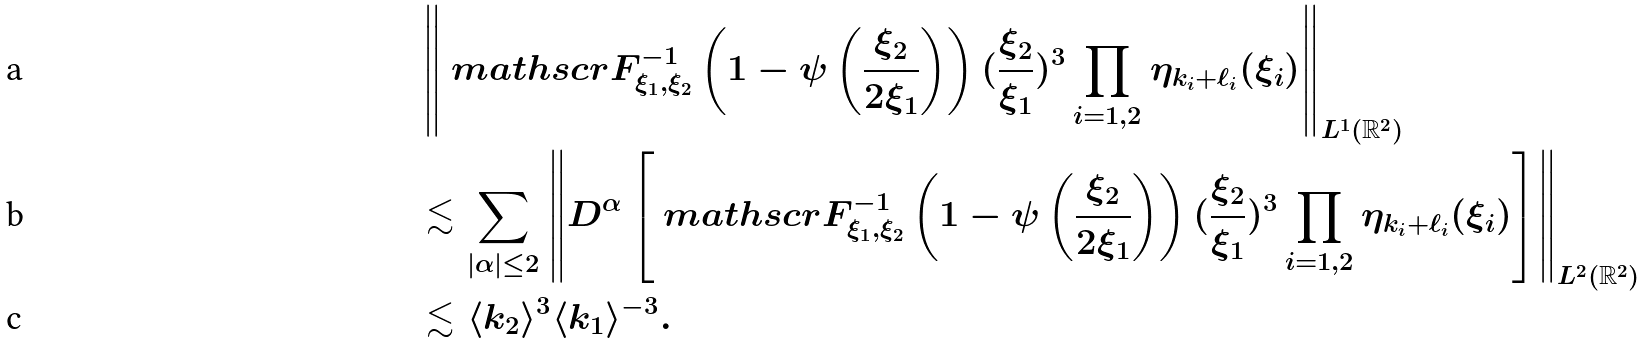Convert formula to latex. <formula><loc_0><loc_0><loc_500><loc_500>& \left \| \ m a t h s c r { F } ^ { - 1 } _ { \xi _ { 1 } , \xi _ { 2 } } \left ( 1 - \psi \left ( \frac { \xi _ { 2 } } { 2 \xi _ { 1 } } \right ) \right ) ( \frac { \xi _ { 2 } } { \xi _ { 1 } } ) ^ { 3 } \prod _ { i = 1 , 2 } \eta _ { k _ { i } + \ell _ { i } } ( \xi _ { i } ) \right \| _ { L ^ { 1 } ( \mathbb { R } ^ { 2 } ) } \\ & \lesssim \sum _ { | \alpha | \leq 2 } \left \| D ^ { \alpha } \left [ \ m a t h s c r { F } ^ { - 1 } _ { \xi _ { 1 } , \xi _ { 2 } } \left ( 1 - \psi \left ( \frac { \xi _ { 2 } } { 2 \xi _ { 1 } } \right ) \right ) ( \frac { \xi _ { 2 } } { \xi _ { 1 } } ) ^ { 3 } \prod _ { i = 1 , 2 } \eta _ { k _ { i } + \ell _ { i } } ( \xi _ { i } ) \right ] \right \| _ { L ^ { 2 } ( \mathbb { R } ^ { 2 } ) } \\ & \lesssim \langle k _ { 2 } \rangle ^ { 3 } \langle k _ { 1 } \rangle ^ { - 3 } .</formula> 